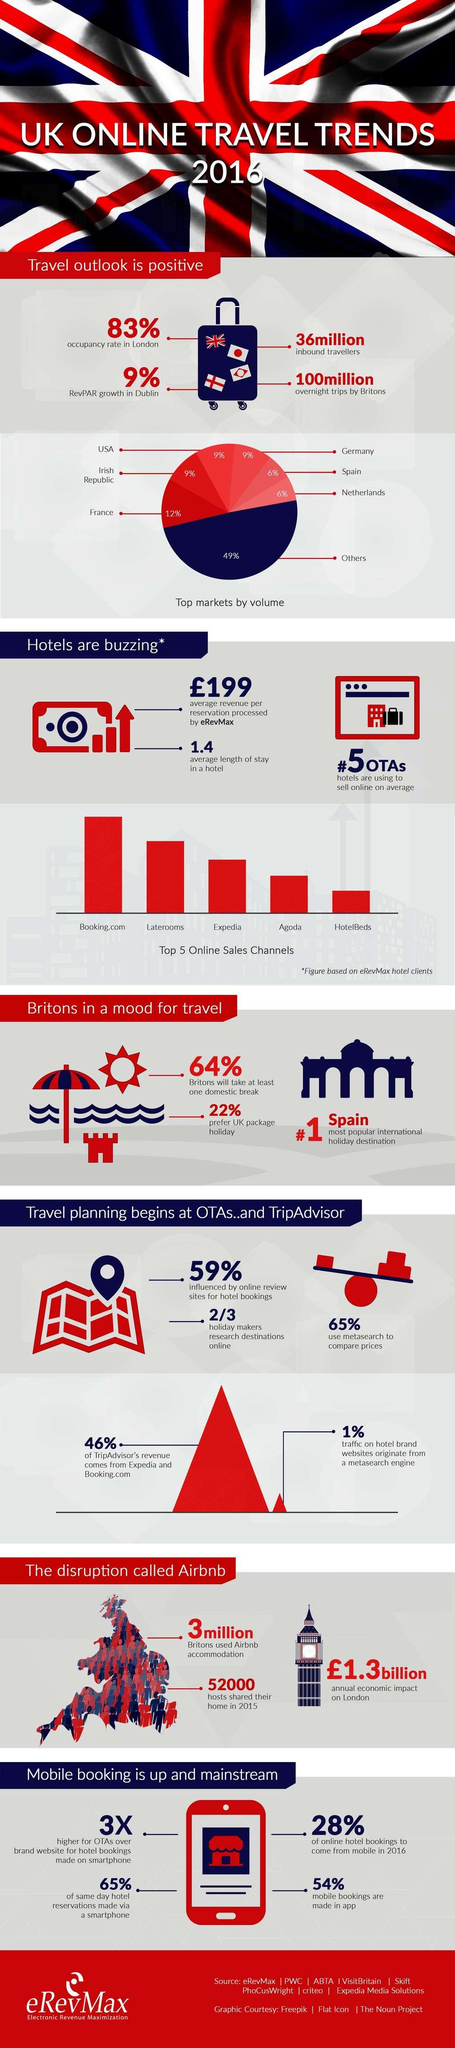Specify some key components in this picture. In 2016, approximately 46% of mobile bookings were made outside of apps. Booking.com was declared as the top online sales channel in the UK in 2016. In 2016, approximately 3 million Britons utilized Airbnb accommodations. Spain is widely recognized as the number one international holiday destination. In 2016, nearly 41% of people in the UK did not let online review sites influence their hotel bookings. 